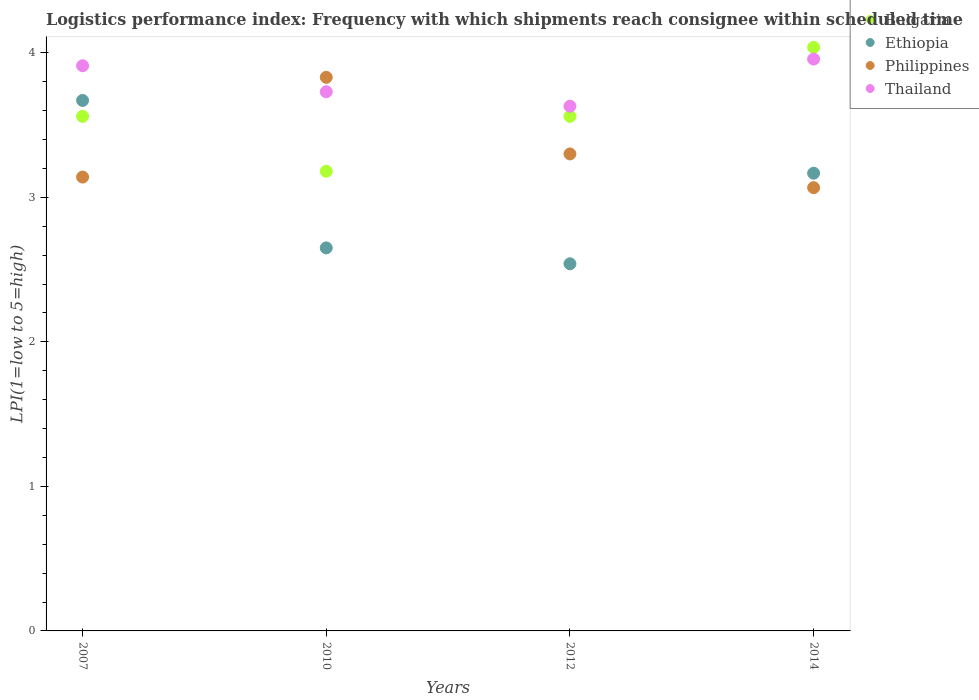How many different coloured dotlines are there?
Ensure brevity in your answer.  4. Is the number of dotlines equal to the number of legend labels?
Ensure brevity in your answer.  Yes. What is the logistics performance index in Ethiopia in 2007?
Offer a terse response. 3.67. Across all years, what is the maximum logistics performance index in Thailand?
Make the answer very short. 3.96. Across all years, what is the minimum logistics performance index in Ethiopia?
Make the answer very short. 2.54. In which year was the logistics performance index in Thailand minimum?
Your answer should be very brief. 2012. What is the total logistics performance index in Bulgaria in the graph?
Offer a very short reply. 14.34. What is the difference between the logistics performance index in Philippines in 2010 and that in 2012?
Give a very brief answer. 0.53. What is the difference between the logistics performance index in Ethiopia in 2014 and the logistics performance index in Bulgaria in 2010?
Provide a short and direct response. -0.01. What is the average logistics performance index in Bulgaria per year?
Keep it short and to the point. 3.58. In the year 2012, what is the difference between the logistics performance index in Bulgaria and logistics performance index in Thailand?
Ensure brevity in your answer.  -0.07. In how many years, is the logistics performance index in Ethiopia greater than 1?
Your response must be concise. 4. What is the ratio of the logistics performance index in Ethiopia in 2007 to that in 2014?
Your answer should be very brief. 1.16. What is the difference between the highest and the second highest logistics performance index in Ethiopia?
Make the answer very short. 0.5. What is the difference between the highest and the lowest logistics performance index in Bulgaria?
Make the answer very short. 0.86. Is the sum of the logistics performance index in Thailand in 2010 and 2014 greater than the maximum logistics performance index in Ethiopia across all years?
Provide a short and direct response. Yes. Does the logistics performance index in Bulgaria monotonically increase over the years?
Your answer should be very brief. No. Is the logistics performance index in Ethiopia strictly greater than the logistics performance index in Thailand over the years?
Provide a succinct answer. No. Is the logistics performance index in Ethiopia strictly less than the logistics performance index in Philippines over the years?
Your answer should be compact. No. How many dotlines are there?
Your answer should be compact. 4. How many years are there in the graph?
Offer a terse response. 4. What is the difference between two consecutive major ticks on the Y-axis?
Offer a terse response. 1. Does the graph contain any zero values?
Offer a terse response. No. Where does the legend appear in the graph?
Provide a succinct answer. Top right. What is the title of the graph?
Keep it short and to the point. Logistics performance index: Frequency with which shipments reach consignee within scheduled time. Does "Swaziland" appear as one of the legend labels in the graph?
Give a very brief answer. No. What is the label or title of the X-axis?
Keep it short and to the point. Years. What is the label or title of the Y-axis?
Offer a very short reply. LPI(1=low to 5=high). What is the LPI(1=low to 5=high) of Bulgaria in 2007?
Make the answer very short. 3.56. What is the LPI(1=low to 5=high) in Ethiopia in 2007?
Provide a succinct answer. 3.67. What is the LPI(1=low to 5=high) in Philippines in 2007?
Provide a short and direct response. 3.14. What is the LPI(1=low to 5=high) of Thailand in 2007?
Offer a very short reply. 3.91. What is the LPI(1=low to 5=high) in Bulgaria in 2010?
Keep it short and to the point. 3.18. What is the LPI(1=low to 5=high) in Ethiopia in 2010?
Offer a terse response. 2.65. What is the LPI(1=low to 5=high) of Philippines in 2010?
Provide a succinct answer. 3.83. What is the LPI(1=low to 5=high) of Thailand in 2010?
Ensure brevity in your answer.  3.73. What is the LPI(1=low to 5=high) of Bulgaria in 2012?
Offer a terse response. 3.56. What is the LPI(1=low to 5=high) of Ethiopia in 2012?
Offer a terse response. 2.54. What is the LPI(1=low to 5=high) in Thailand in 2012?
Keep it short and to the point. 3.63. What is the LPI(1=low to 5=high) of Bulgaria in 2014?
Give a very brief answer. 4.04. What is the LPI(1=low to 5=high) in Ethiopia in 2014?
Provide a succinct answer. 3.17. What is the LPI(1=low to 5=high) in Philippines in 2014?
Provide a succinct answer. 3.07. What is the LPI(1=low to 5=high) in Thailand in 2014?
Keep it short and to the point. 3.96. Across all years, what is the maximum LPI(1=low to 5=high) of Bulgaria?
Provide a short and direct response. 4.04. Across all years, what is the maximum LPI(1=low to 5=high) of Ethiopia?
Provide a succinct answer. 3.67. Across all years, what is the maximum LPI(1=low to 5=high) in Philippines?
Provide a succinct answer. 3.83. Across all years, what is the maximum LPI(1=low to 5=high) in Thailand?
Offer a terse response. 3.96. Across all years, what is the minimum LPI(1=low to 5=high) of Bulgaria?
Provide a short and direct response. 3.18. Across all years, what is the minimum LPI(1=low to 5=high) of Ethiopia?
Provide a succinct answer. 2.54. Across all years, what is the minimum LPI(1=low to 5=high) of Philippines?
Your answer should be very brief. 3.07. Across all years, what is the minimum LPI(1=low to 5=high) in Thailand?
Offer a very short reply. 3.63. What is the total LPI(1=low to 5=high) in Bulgaria in the graph?
Your response must be concise. 14.34. What is the total LPI(1=low to 5=high) in Ethiopia in the graph?
Offer a very short reply. 12.03. What is the total LPI(1=low to 5=high) of Philippines in the graph?
Give a very brief answer. 13.34. What is the total LPI(1=low to 5=high) of Thailand in the graph?
Offer a very short reply. 15.23. What is the difference between the LPI(1=low to 5=high) in Bulgaria in 2007 and that in 2010?
Your response must be concise. 0.38. What is the difference between the LPI(1=low to 5=high) in Philippines in 2007 and that in 2010?
Your response must be concise. -0.69. What is the difference between the LPI(1=low to 5=high) of Thailand in 2007 and that in 2010?
Ensure brevity in your answer.  0.18. What is the difference between the LPI(1=low to 5=high) of Bulgaria in 2007 and that in 2012?
Your answer should be very brief. 0. What is the difference between the LPI(1=low to 5=high) in Ethiopia in 2007 and that in 2012?
Your response must be concise. 1.13. What is the difference between the LPI(1=low to 5=high) in Philippines in 2007 and that in 2012?
Make the answer very short. -0.16. What is the difference between the LPI(1=low to 5=high) of Thailand in 2007 and that in 2012?
Your answer should be compact. 0.28. What is the difference between the LPI(1=low to 5=high) in Bulgaria in 2007 and that in 2014?
Offer a terse response. -0.48. What is the difference between the LPI(1=low to 5=high) in Ethiopia in 2007 and that in 2014?
Offer a terse response. 0.5. What is the difference between the LPI(1=low to 5=high) in Philippines in 2007 and that in 2014?
Your answer should be compact. 0.07. What is the difference between the LPI(1=low to 5=high) of Thailand in 2007 and that in 2014?
Provide a succinct answer. -0.05. What is the difference between the LPI(1=low to 5=high) in Bulgaria in 2010 and that in 2012?
Your response must be concise. -0.38. What is the difference between the LPI(1=low to 5=high) in Ethiopia in 2010 and that in 2012?
Offer a very short reply. 0.11. What is the difference between the LPI(1=low to 5=high) in Philippines in 2010 and that in 2012?
Provide a short and direct response. 0.53. What is the difference between the LPI(1=low to 5=high) of Thailand in 2010 and that in 2012?
Provide a short and direct response. 0.1. What is the difference between the LPI(1=low to 5=high) of Bulgaria in 2010 and that in 2014?
Make the answer very short. -0.86. What is the difference between the LPI(1=low to 5=high) of Ethiopia in 2010 and that in 2014?
Ensure brevity in your answer.  -0.52. What is the difference between the LPI(1=low to 5=high) of Philippines in 2010 and that in 2014?
Provide a short and direct response. 0.76. What is the difference between the LPI(1=low to 5=high) of Thailand in 2010 and that in 2014?
Offer a very short reply. -0.23. What is the difference between the LPI(1=low to 5=high) in Bulgaria in 2012 and that in 2014?
Offer a terse response. -0.48. What is the difference between the LPI(1=low to 5=high) of Ethiopia in 2012 and that in 2014?
Your answer should be very brief. -0.63. What is the difference between the LPI(1=low to 5=high) of Philippines in 2012 and that in 2014?
Your response must be concise. 0.23. What is the difference between the LPI(1=low to 5=high) of Thailand in 2012 and that in 2014?
Ensure brevity in your answer.  -0.33. What is the difference between the LPI(1=low to 5=high) in Bulgaria in 2007 and the LPI(1=low to 5=high) in Ethiopia in 2010?
Ensure brevity in your answer.  0.91. What is the difference between the LPI(1=low to 5=high) of Bulgaria in 2007 and the LPI(1=low to 5=high) of Philippines in 2010?
Offer a very short reply. -0.27. What is the difference between the LPI(1=low to 5=high) of Bulgaria in 2007 and the LPI(1=low to 5=high) of Thailand in 2010?
Your answer should be compact. -0.17. What is the difference between the LPI(1=low to 5=high) of Ethiopia in 2007 and the LPI(1=low to 5=high) of Philippines in 2010?
Ensure brevity in your answer.  -0.16. What is the difference between the LPI(1=low to 5=high) of Ethiopia in 2007 and the LPI(1=low to 5=high) of Thailand in 2010?
Keep it short and to the point. -0.06. What is the difference between the LPI(1=low to 5=high) of Philippines in 2007 and the LPI(1=low to 5=high) of Thailand in 2010?
Offer a terse response. -0.59. What is the difference between the LPI(1=low to 5=high) of Bulgaria in 2007 and the LPI(1=low to 5=high) of Ethiopia in 2012?
Provide a short and direct response. 1.02. What is the difference between the LPI(1=low to 5=high) of Bulgaria in 2007 and the LPI(1=low to 5=high) of Philippines in 2012?
Keep it short and to the point. 0.26. What is the difference between the LPI(1=low to 5=high) in Bulgaria in 2007 and the LPI(1=low to 5=high) in Thailand in 2012?
Your response must be concise. -0.07. What is the difference between the LPI(1=low to 5=high) of Ethiopia in 2007 and the LPI(1=low to 5=high) of Philippines in 2012?
Your response must be concise. 0.37. What is the difference between the LPI(1=low to 5=high) of Philippines in 2007 and the LPI(1=low to 5=high) of Thailand in 2012?
Ensure brevity in your answer.  -0.49. What is the difference between the LPI(1=low to 5=high) in Bulgaria in 2007 and the LPI(1=low to 5=high) in Ethiopia in 2014?
Provide a short and direct response. 0.39. What is the difference between the LPI(1=low to 5=high) of Bulgaria in 2007 and the LPI(1=low to 5=high) of Philippines in 2014?
Your answer should be very brief. 0.49. What is the difference between the LPI(1=low to 5=high) of Bulgaria in 2007 and the LPI(1=low to 5=high) of Thailand in 2014?
Offer a terse response. -0.4. What is the difference between the LPI(1=low to 5=high) in Ethiopia in 2007 and the LPI(1=low to 5=high) in Philippines in 2014?
Offer a very short reply. 0.6. What is the difference between the LPI(1=low to 5=high) of Ethiopia in 2007 and the LPI(1=low to 5=high) of Thailand in 2014?
Keep it short and to the point. -0.29. What is the difference between the LPI(1=low to 5=high) of Philippines in 2007 and the LPI(1=low to 5=high) of Thailand in 2014?
Your answer should be very brief. -0.82. What is the difference between the LPI(1=low to 5=high) in Bulgaria in 2010 and the LPI(1=low to 5=high) in Ethiopia in 2012?
Provide a succinct answer. 0.64. What is the difference between the LPI(1=low to 5=high) of Bulgaria in 2010 and the LPI(1=low to 5=high) of Philippines in 2012?
Ensure brevity in your answer.  -0.12. What is the difference between the LPI(1=low to 5=high) of Bulgaria in 2010 and the LPI(1=low to 5=high) of Thailand in 2012?
Your answer should be very brief. -0.45. What is the difference between the LPI(1=low to 5=high) in Ethiopia in 2010 and the LPI(1=low to 5=high) in Philippines in 2012?
Offer a terse response. -0.65. What is the difference between the LPI(1=low to 5=high) in Ethiopia in 2010 and the LPI(1=low to 5=high) in Thailand in 2012?
Your answer should be very brief. -0.98. What is the difference between the LPI(1=low to 5=high) in Bulgaria in 2010 and the LPI(1=low to 5=high) in Ethiopia in 2014?
Ensure brevity in your answer.  0.01. What is the difference between the LPI(1=low to 5=high) of Bulgaria in 2010 and the LPI(1=low to 5=high) of Philippines in 2014?
Give a very brief answer. 0.11. What is the difference between the LPI(1=low to 5=high) in Bulgaria in 2010 and the LPI(1=low to 5=high) in Thailand in 2014?
Ensure brevity in your answer.  -0.78. What is the difference between the LPI(1=low to 5=high) of Ethiopia in 2010 and the LPI(1=low to 5=high) of Philippines in 2014?
Provide a short and direct response. -0.42. What is the difference between the LPI(1=low to 5=high) in Ethiopia in 2010 and the LPI(1=low to 5=high) in Thailand in 2014?
Give a very brief answer. -1.31. What is the difference between the LPI(1=low to 5=high) of Philippines in 2010 and the LPI(1=low to 5=high) of Thailand in 2014?
Offer a terse response. -0.13. What is the difference between the LPI(1=low to 5=high) in Bulgaria in 2012 and the LPI(1=low to 5=high) in Ethiopia in 2014?
Provide a succinct answer. 0.39. What is the difference between the LPI(1=low to 5=high) of Bulgaria in 2012 and the LPI(1=low to 5=high) of Philippines in 2014?
Offer a very short reply. 0.49. What is the difference between the LPI(1=low to 5=high) of Bulgaria in 2012 and the LPI(1=low to 5=high) of Thailand in 2014?
Your response must be concise. -0.4. What is the difference between the LPI(1=low to 5=high) of Ethiopia in 2012 and the LPI(1=low to 5=high) of Philippines in 2014?
Ensure brevity in your answer.  -0.53. What is the difference between the LPI(1=low to 5=high) in Ethiopia in 2012 and the LPI(1=low to 5=high) in Thailand in 2014?
Offer a terse response. -1.42. What is the difference between the LPI(1=low to 5=high) in Philippines in 2012 and the LPI(1=low to 5=high) in Thailand in 2014?
Provide a succinct answer. -0.66. What is the average LPI(1=low to 5=high) in Bulgaria per year?
Offer a terse response. 3.58. What is the average LPI(1=low to 5=high) in Ethiopia per year?
Your answer should be compact. 3.01. What is the average LPI(1=low to 5=high) in Philippines per year?
Provide a succinct answer. 3.33. What is the average LPI(1=low to 5=high) of Thailand per year?
Ensure brevity in your answer.  3.81. In the year 2007, what is the difference between the LPI(1=low to 5=high) in Bulgaria and LPI(1=low to 5=high) in Ethiopia?
Offer a very short reply. -0.11. In the year 2007, what is the difference between the LPI(1=low to 5=high) of Bulgaria and LPI(1=low to 5=high) of Philippines?
Provide a short and direct response. 0.42. In the year 2007, what is the difference between the LPI(1=low to 5=high) in Bulgaria and LPI(1=low to 5=high) in Thailand?
Offer a terse response. -0.35. In the year 2007, what is the difference between the LPI(1=low to 5=high) of Ethiopia and LPI(1=low to 5=high) of Philippines?
Give a very brief answer. 0.53. In the year 2007, what is the difference between the LPI(1=low to 5=high) of Ethiopia and LPI(1=low to 5=high) of Thailand?
Offer a very short reply. -0.24. In the year 2007, what is the difference between the LPI(1=low to 5=high) in Philippines and LPI(1=low to 5=high) in Thailand?
Your answer should be compact. -0.77. In the year 2010, what is the difference between the LPI(1=low to 5=high) of Bulgaria and LPI(1=low to 5=high) of Ethiopia?
Your response must be concise. 0.53. In the year 2010, what is the difference between the LPI(1=low to 5=high) in Bulgaria and LPI(1=low to 5=high) in Philippines?
Your answer should be very brief. -0.65. In the year 2010, what is the difference between the LPI(1=low to 5=high) of Bulgaria and LPI(1=low to 5=high) of Thailand?
Give a very brief answer. -0.55. In the year 2010, what is the difference between the LPI(1=low to 5=high) in Ethiopia and LPI(1=low to 5=high) in Philippines?
Offer a very short reply. -1.18. In the year 2010, what is the difference between the LPI(1=low to 5=high) in Ethiopia and LPI(1=low to 5=high) in Thailand?
Keep it short and to the point. -1.08. In the year 2010, what is the difference between the LPI(1=low to 5=high) of Philippines and LPI(1=low to 5=high) of Thailand?
Make the answer very short. 0.1. In the year 2012, what is the difference between the LPI(1=low to 5=high) in Bulgaria and LPI(1=low to 5=high) in Philippines?
Make the answer very short. 0.26. In the year 2012, what is the difference between the LPI(1=low to 5=high) in Bulgaria and LPI(1=low to 5=high) in Thailand?
Provide a short and direct response. -0.07. In the year 2012, what is the difference between the LPI(1=low to 5=high) in Ethiopia and LPI(1=low to 5=high) in Philippines?
Ensure brevity in your answer.  -0.76. In the year 2012, what is the difference between the LPI(1=low to 5=high) of Ethiopia and LPI(1=low to 5=high) of Thailand?
Your answer should be very brief. -1.09. In the year 2012, what is the difference between the LPI(1=low to 5=high) of Philippines and LPI(1=low to 5=high) of Thailand?
Your answer should be very brief. -0.33. In the year 2014, what is the difference between the LPI(1=low to 5=high) in Bulgaria and LPI(1=low to 5=high) in Ethiopia?
Provide a succinct answer. 0.87. In the year 2014, what is the difference between the LPI(1=low to 5=high) of Bulgaria and LPI(1=low to 5=high) of Philippines?
Offer a very short reply. 0.97. In the year 2014, what is the difference between the LPI(1=low to 5=high) of Bulgaria and LPI(1=low to 5=high) of Thailand?
Your answer should be very brief. 0.08. In the year 2014, what is the difference between the LPI(1=low to 5=high) in Ethiopia and LPI(1=low to 5=high) in Philippines?
Your answer should be compact. 0.1. In the year 2014, what is the difference between the LPI(1=low to 5=high) in Ethiopia and LPI(1=low to 5=high) in Thailand?
Keep it short and to the point. -0.79. In the year 2014, what is the difference between the LPI(1=low to 5=high) of Philippines and LPI(1=low to 5=high) of Thailand?
Ensure brevity in your answer.  -0.89. What is the ratio of the LPI(1=low to 5=high) of Bulgaria in 2007 to that in 2010?
Provide a short and direct response. 1.12. What is the ratio of the LPI(1=low to 5=high) of Ethiopia in 2007 to that in 2010?
Offer a very short reply. 1.38. What is the ratio of the LPI(1=low to 5=high) of Philippines in 2007 to that in 2010?
Provide a short and direct response. 0.82. What is the ratio of the LPI(1=low to 5=high) in Thailand in 2007 to that in 2010?
Provide a short and direct response. 1.05. What is the ratio of the LPI(1=low to 5=high) in Ethiopia in 2007 to that in 2012?
Your answer should be very brief. 1.44. What is the ratio of the LPI(1=low to 5=high) in Philippines in 2007 to that in 2012?
Offer a terse response. 0.95. What is the ratio of the LPI(1=low to 5=high) in Thailand in 2007 to that in 2012?
Offer a very short reply. 1.08. What is the ratio of the LPI(1=low to 5=high) of Bulgaria in 2007 to that in 2014?
Your answer should be very brief. 0.88. What is the ratio of the LPI(1=low to 5=high) of Ethiopia in 2007 to that in 2014?
Your answer should be compact. 1.16. What is the ratio of the LPI(1=low to 5=high) of Philippines in 2007 to that in 2014?
Make the answer very short. 1.02. What is the ratio of the LPI(1=low to 5=high) of Thailand in 2007 to that in 2014?
Make the answer very short. 0.99. What is the ratio of the LPI(1=low to 5=high) in Bulgaria in 2010 to that in 2012?
Your answer should be compact. 0.89. What is the ratio of the LPI(1=low to 5=high) in Ethiopia in 2010 to that in 2012?
Your response must be concise. 1.04. What is the ratio of the LPI(1=low to 5=high) of Philippines in 2010 to that in 2012?
Offer a very short reply. 1.16. What is the ratio of the LPI(1=low to 5=high) of Thailand in 2010 to that in 2012?
Make the answer very short. 1.03. What is the ratio of the LPI(1=low to 5=high) in Bulgaria in 2010 to that in 2014?
Provide a succinct answer. 0.79. What is the ratio of the LPI(1=low to 5=high) of Ethiopia in 2010 to that in 2014?
Give a very brief answer. 0.84. What is the ratio of the LPI(1=low to 5=high) of Philippines in 2010 to that in 2014?
Your response must be concise. 1.25. What is the ratio of the LPI(1=low to 5=high) in Thailand in 2010 to that in 2014?
Offer a terse response. 0.94. What is the ratio of the LPI(1=low to 5=high) in Bulgaria in 2012 to that in 2014?
Offer a terse response. 0.88. What is the ratio of the LPI(1=low to 5=high) of Ethiopia in 2012 to that in 2014?
Provide a succinct answer. 0.8. What is the ratio of the LPI(1=low to 5=high) of Philippines in 2012 to that in 2014?
Your answer should be very brief. 1.08. What is the ratio of the LPI(1=low to 5=high) of Thailand in 2012 to that in 2014?
Provide a succinct answer. 0.92. What is the difference between the highest and the second highest LPI(1=low to 5=high) in Bulgaria?
Your answer should be very brief. 0.48. What is the difference between the highest and the second highest LPI(1=low to 5=high) in Ethiopia?
Offer a very short reply. 0.5. What is the difference between the highest and the second highest LPI(1=low to 5=high) in Philippines?
Offer a very short reply. 0.53. What is the difference between the highest and the second highest LPI(1=low to 5=high) in Thailand?
Keep it short and to the point. 0.05. What is the difference between the highest and the lowest LPI(1=low to 5=high) of Ethiopia?
Give a very brief answer. 1.13. What is the difference between the highest and the lowest LPI(1=low to 5=high) in Philippines?
Give a very brief answer. 0.76. What is the difference between the highest and the lowest LPI(1=low to 5=high) of Thailand?
Provide a short and direct response. 0.33. 